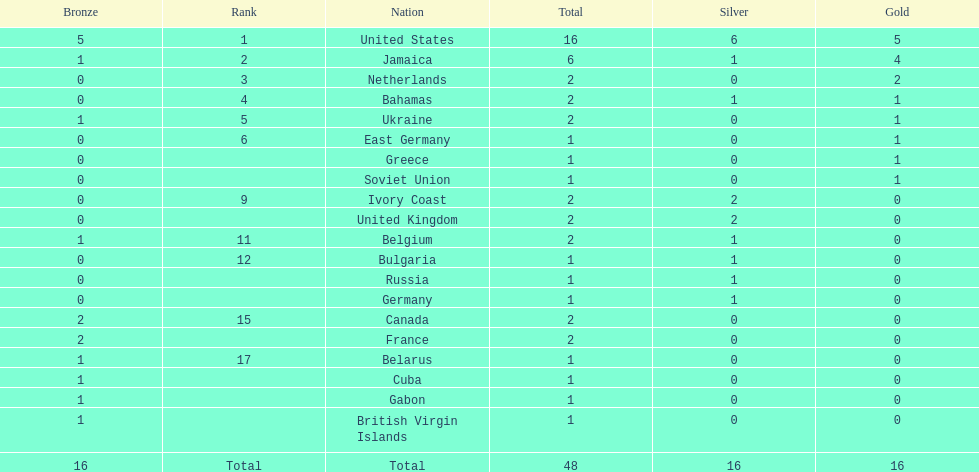How many nations won more than one silver medal? 3. 